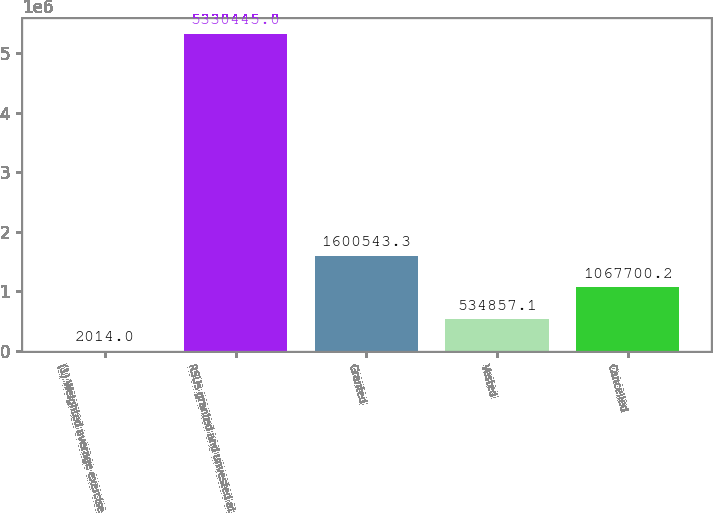Convert chart. <chart><loc_0><loc_0><loc_500><loc_500><bar_chart><fcel>(1) Weighted average exercise<fcel>RSUs granted and unvested at<fcel>Granted<fcel>Vested<fcel>Cancelled<nl><fcel>2014<fcel>5.33044e+06<fcel>1.60054e+06<fcel>534857<fcel>1.0677e+06<nl></chart> 